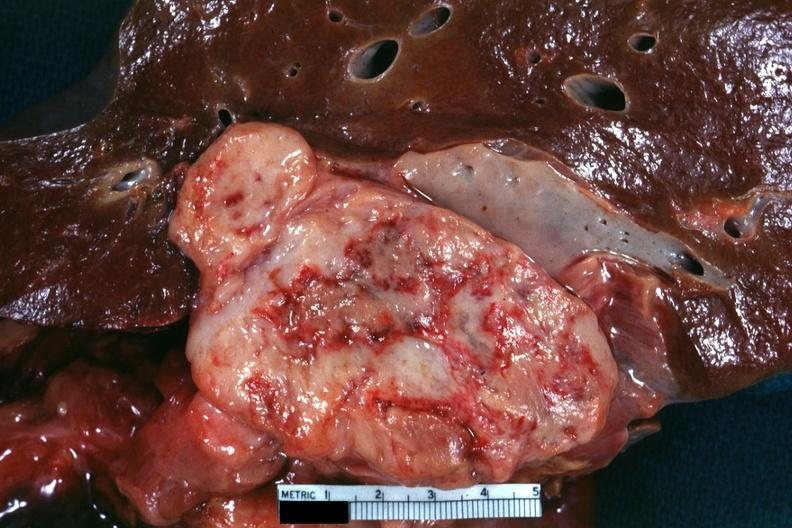what is present?
Answer the question using a single word or phrase. Leiomyosarcoma 